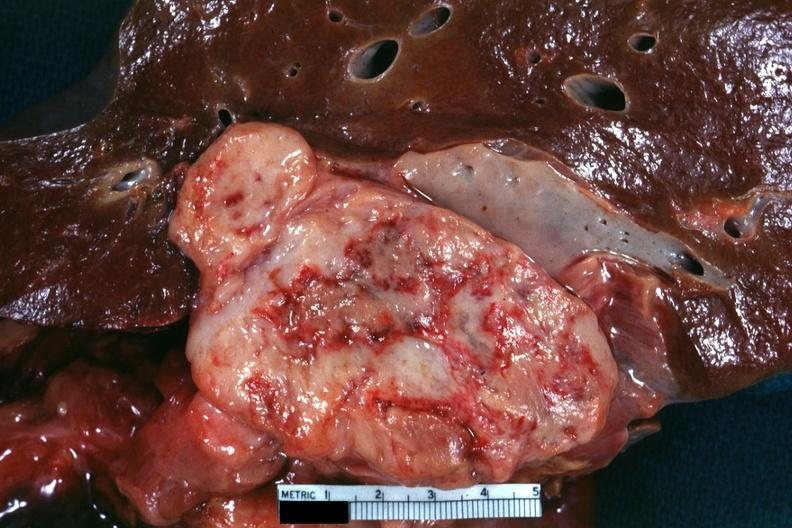what is present?
Answer the question using a single word or phrase. Leiomyosarcoma 